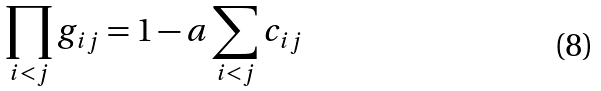<formula> <loc_0><loc_0><loc_500><loc_500>\prod _ { i < j } g _ { i j } = 1 - a \sum _ { i < j } c _ { i j }</formula> 